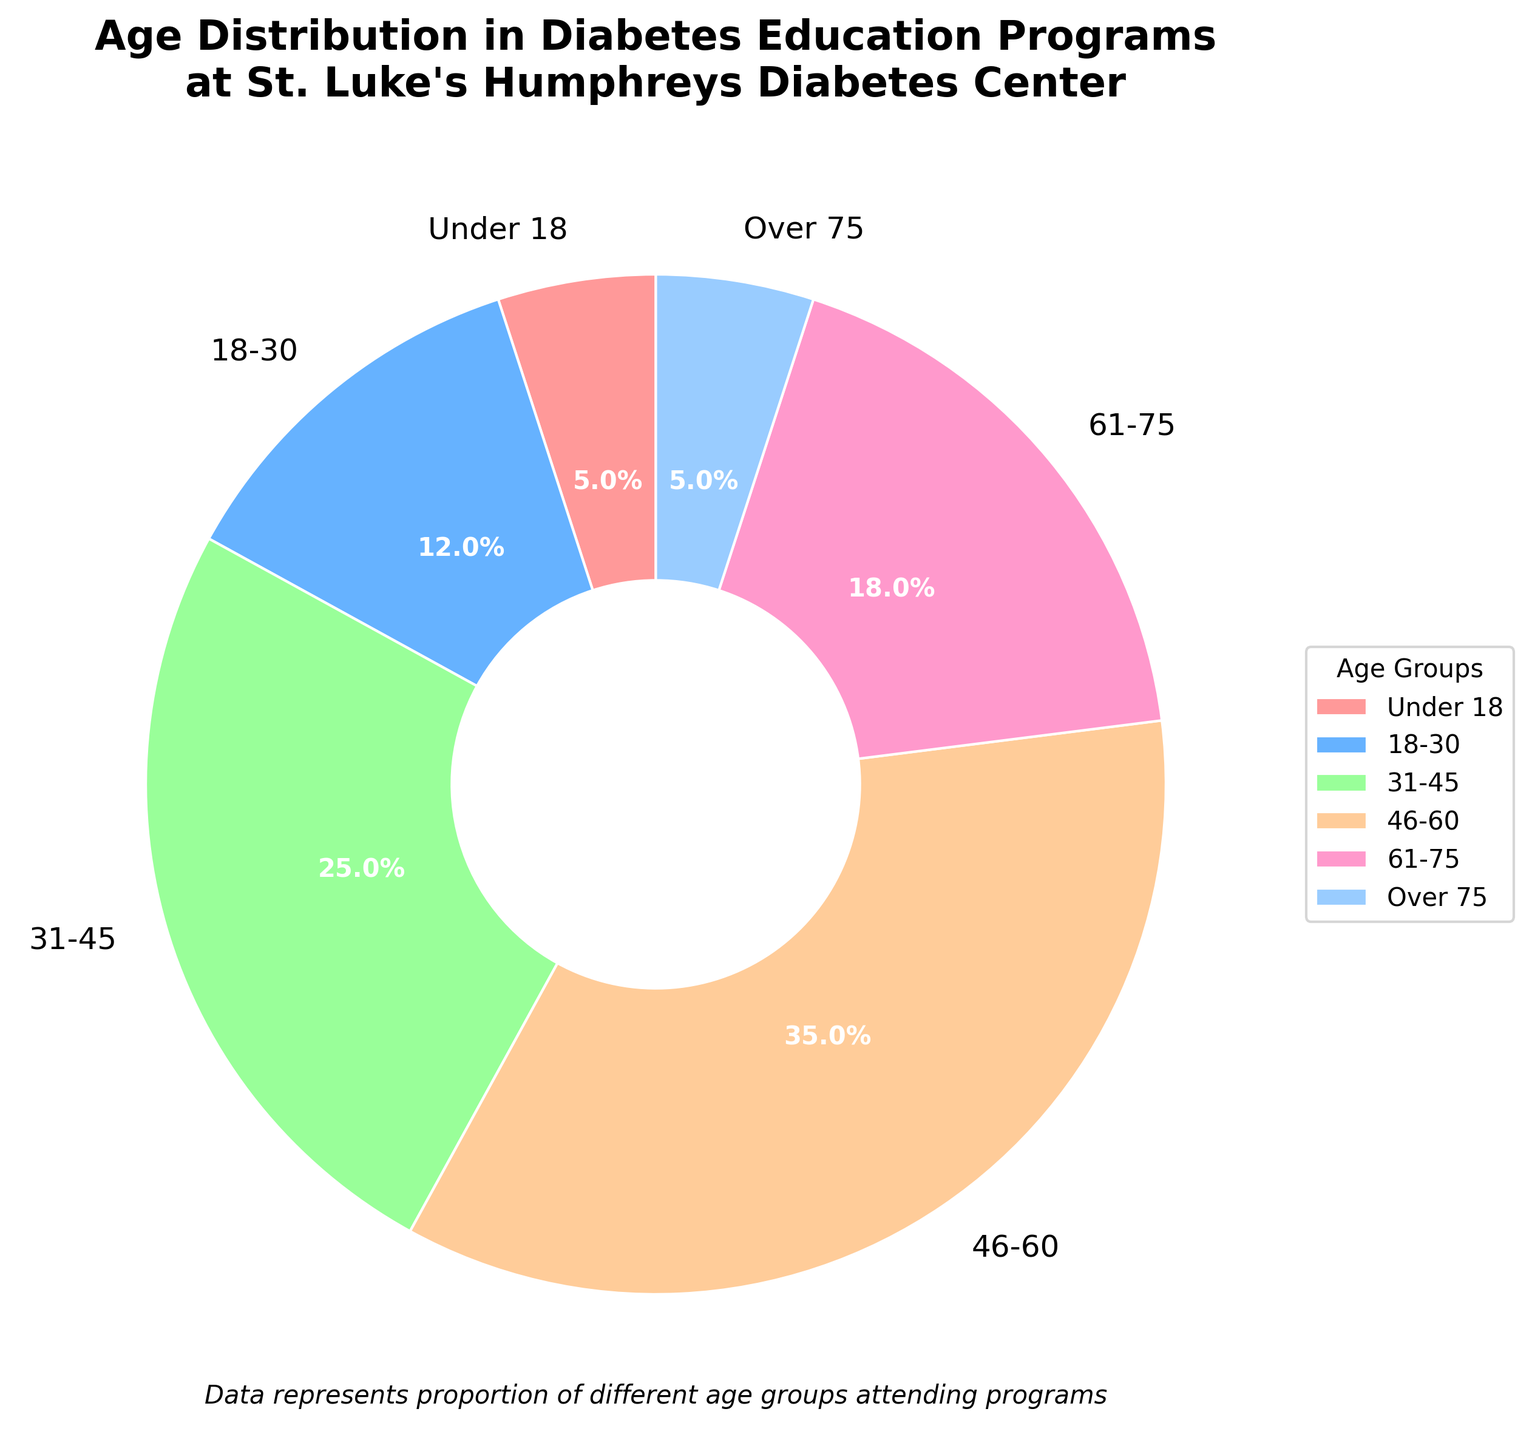Which age group has the highest percentage in the diabetes education programs? Looking at the pie chart, the segment with the largest size and percentage is between 46-60
Answer: 46-60 How many age groups have a percentage less than 10%? Observing the slices of the pie chart, the 'Under 18' and 'Over 75' sections both have a percentage of 5% each, which are the only groups under 10%
Answer: 2 What's the combined percentage of age groups above 60 years? Summing up the percentages for '61-75' and 'Over 75' age groups, which are 18% and 5% respectively, results in a total percentage of 18 + 5 = 23%
Answer: 23% Which color represents the '18-30' age group, and what is its percentage? The '18-30' age group is represented by the blue segment, with a percentage of 12%, easily identifiable by looking at the pie chart's colors and labels
Answer: Blue, 12% How does the percentage of the '31-45' age group compare to the '61-75' age group? The chart shows that the '31-45' age group has 25%, which is greater than the '61-75' age group's 18%, so the '31-45' group is larger
Answer: Greater If you sum the percentages of the three youngest age groups, what is the total percentage? Adding the percentages for the 'Under 18' (5%), '18-30' (12%), and '31-45' (25%) age groups together gives 5 + 12 + 25 = 42%
Answer: 42% What is the difference in percentage between the 'Under 18' age group and the '61-75' age group? Subtracting the 'Under 18' percentage (5%) from the '61-75' percentage (18%) results in 18 - 5 = 13% difference
Answer: 13% Which age group has the same percentage, and how is this visually indicated? The 'Under 18' and 'Over 75' age groups both have 5%, indicated by similar-sized segments in the pie chart
Answer: Under 18 and Over 75, same size segments 